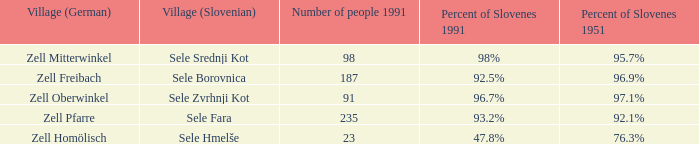Provide me with the name of the village (German) where there is 96.9% Slovenes in 1951.  Zell Freibach. 